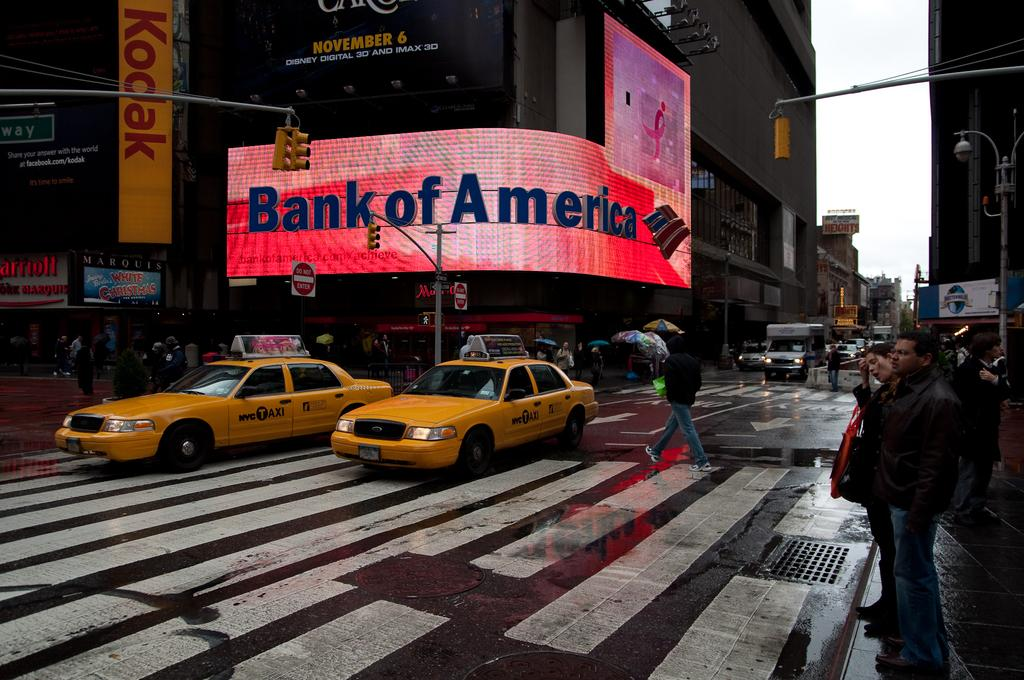<image>
Write a terse but informative summary of the picture. A city scene with a large Bank of America sign. 